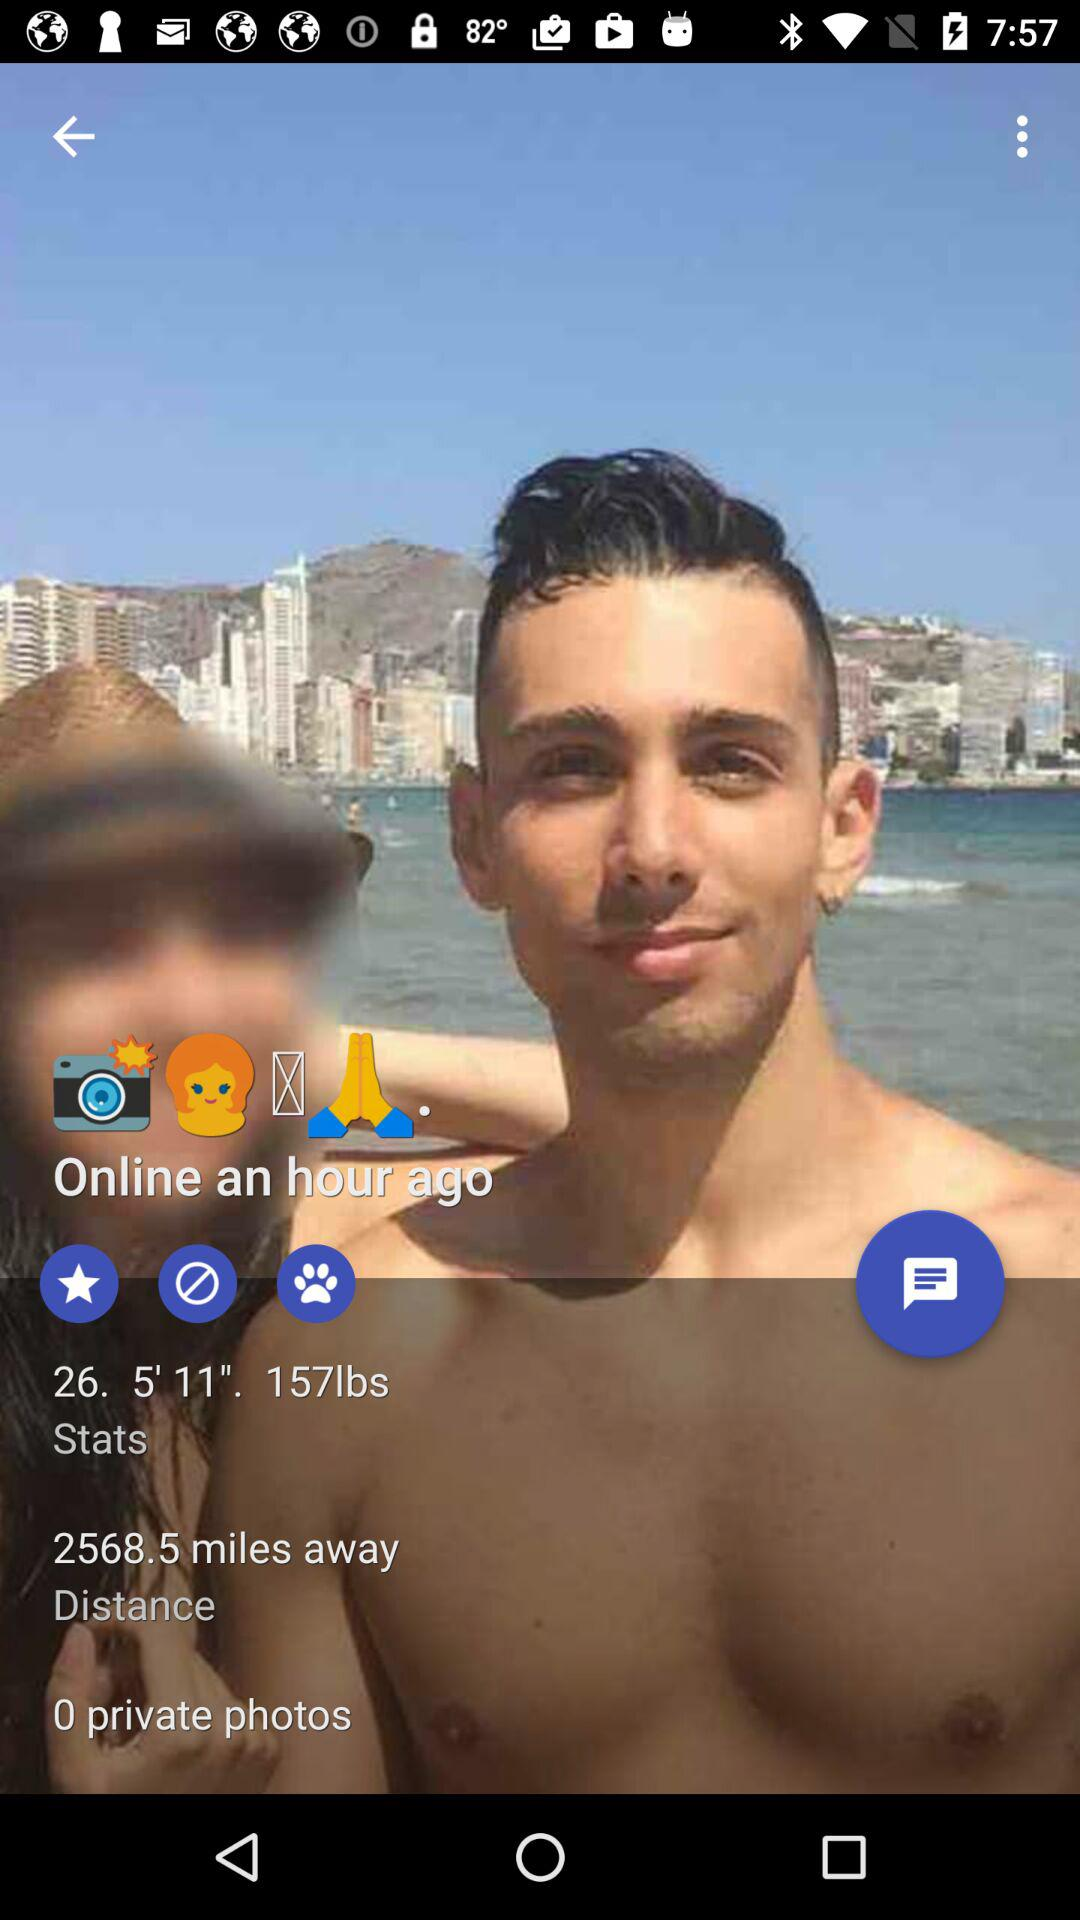What is the weight of the user? The weight of the user is 157 lbs. 